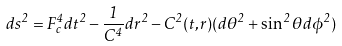Convert formula to latex. <formula><loc_0><loc_0><loc_500><loc_500>d s ^ { 2 } = F _ { c } ^ { 4 } d t ^ { 2 } - \frac { 1 } { C ^ { 4 } } d r ^ { 2 } - C ^ { 2 } ( t , r ) ( d \theta ^ { 2 } + \sin ^ { 2 } \theta d \phi ^ { 2 } )</formula> 